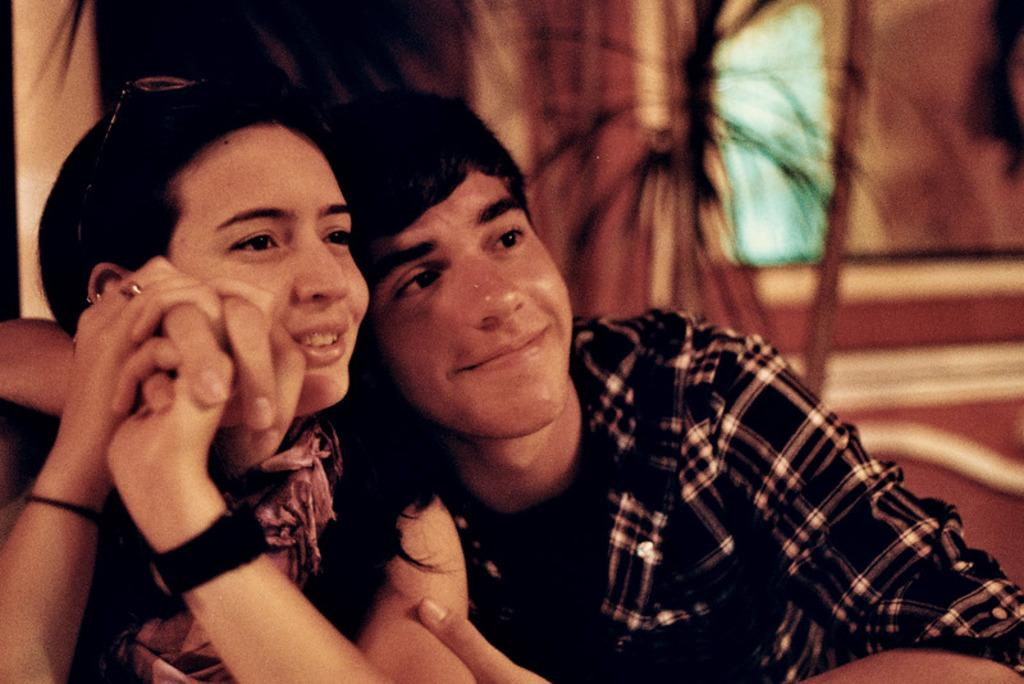How many people are in the image? There are two people in the image. What is the facial expression of the people in the image? Both people are smiling. What can be observed about the clothing of the people in the image? The people are wearing different color dresses. What colors are present in the background of the image? The background of the image is in brown, white, and black colors. How is the background of the image depicted? The background is blurred. What is the condition of the brain of the person on the left? There is no brain visible in the image, so it is not possible to determine its condition. 